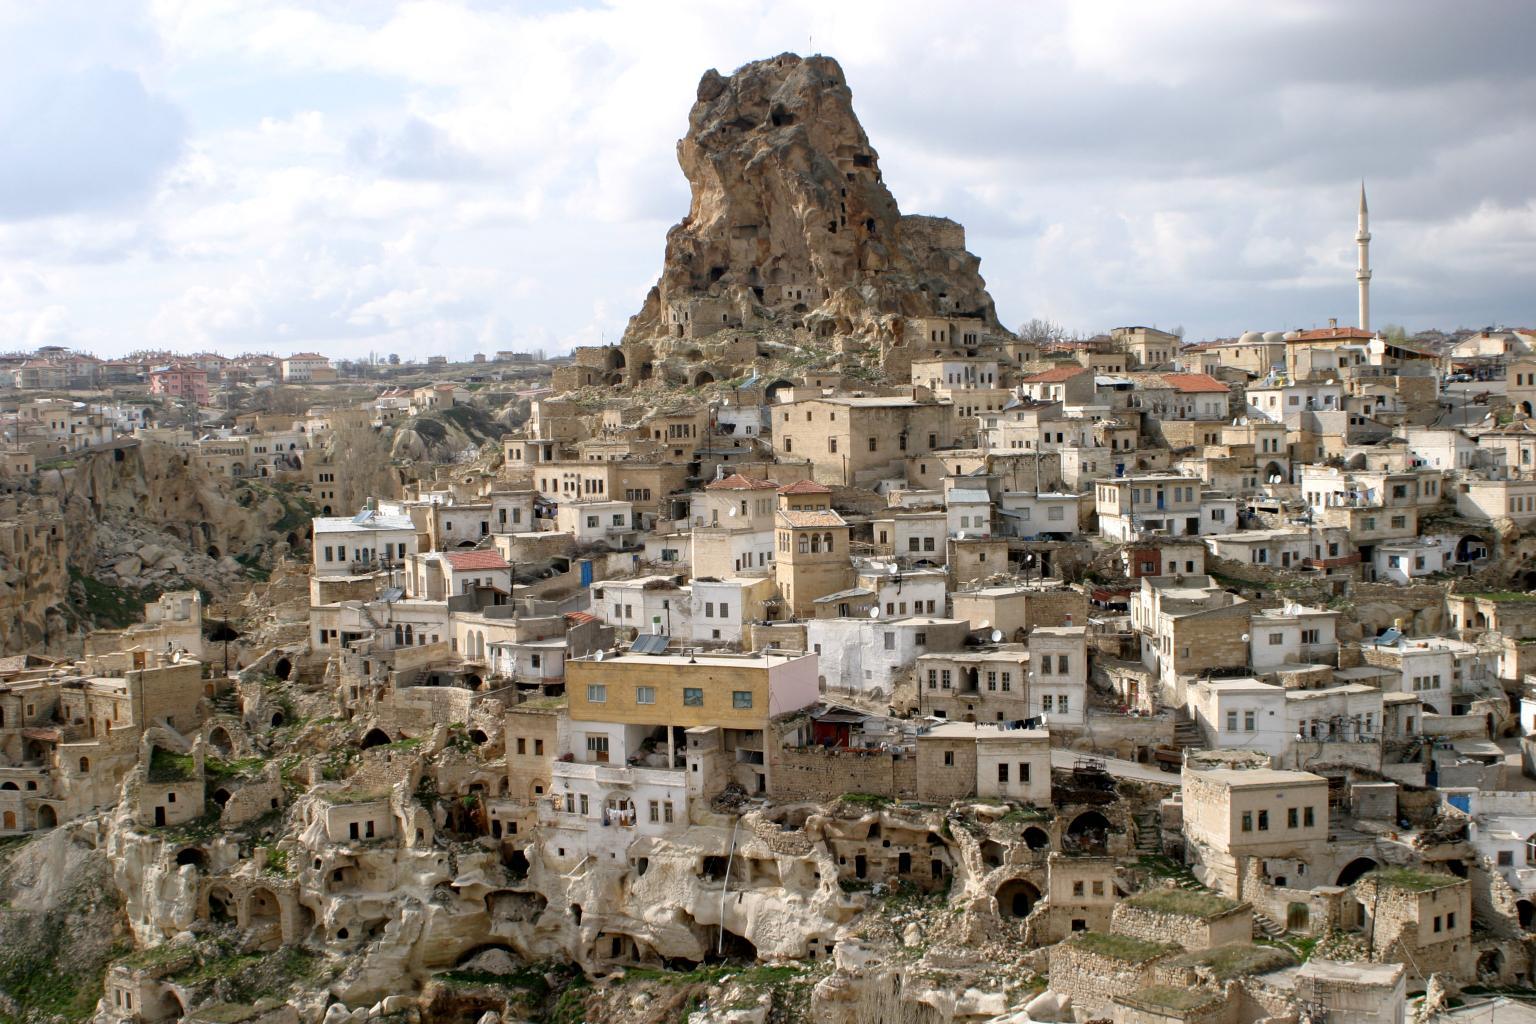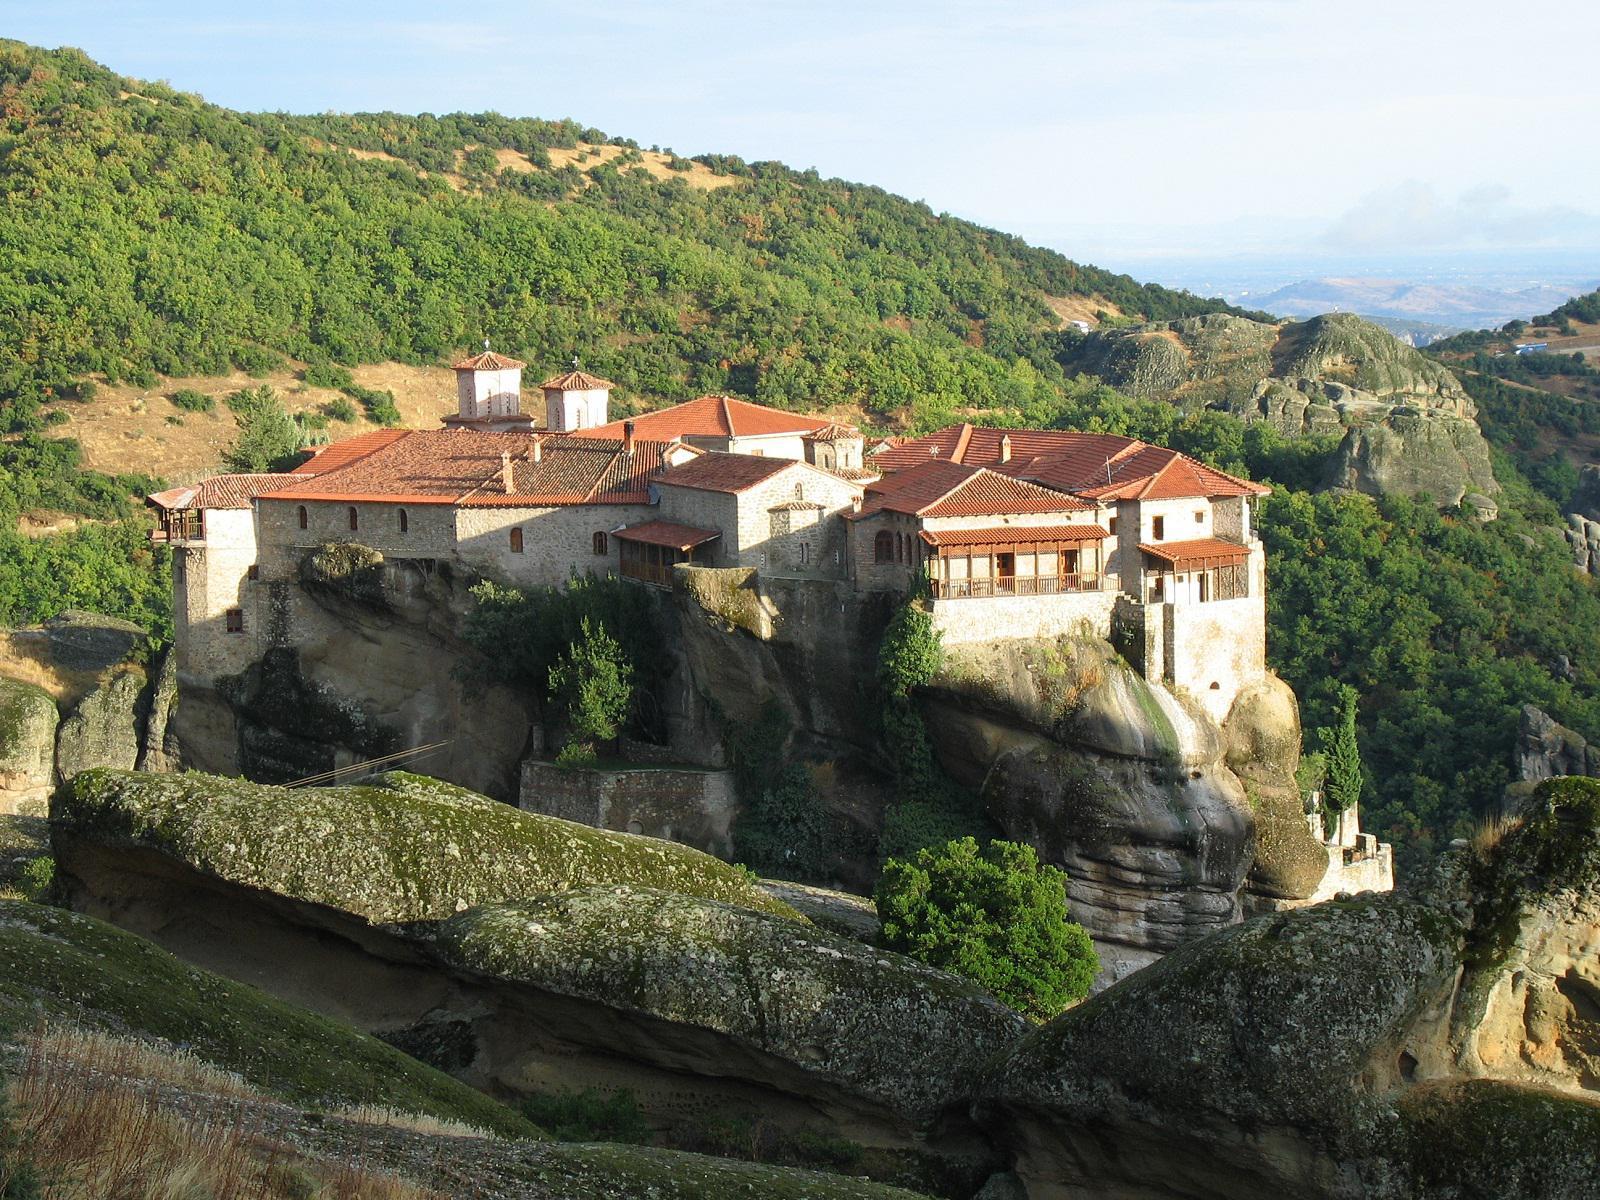The first image is the image on the left, the second image is the image on the right. For the images displayed, is the sentence "Right image features buildings with red-orange roofs on a rocky hilltop, while left image does not." factually correct? Answer yes or no. Yes. 